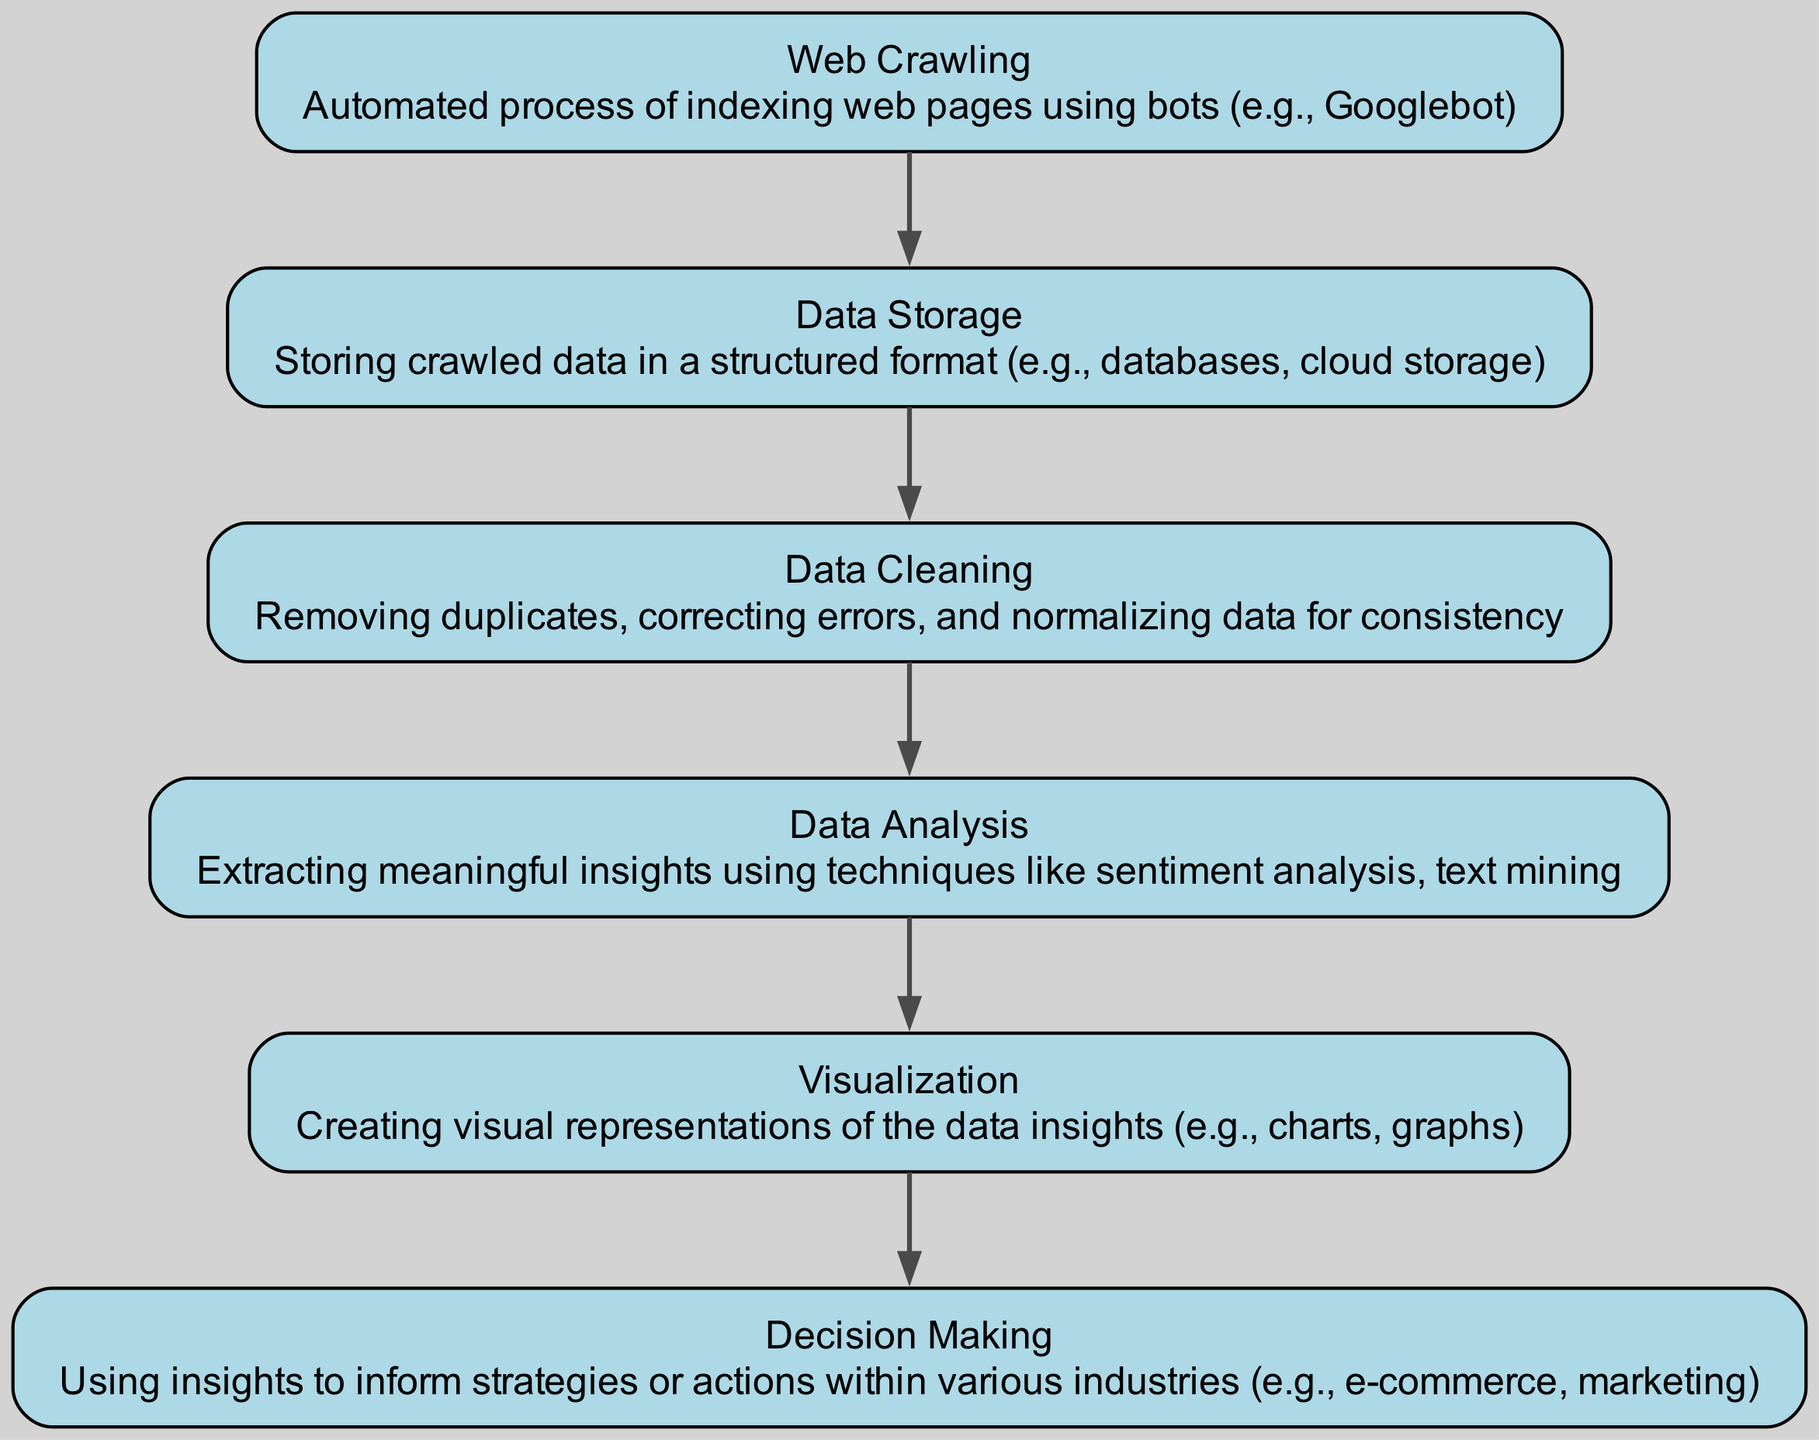What is the first step in the diagram? The first step, as indicated by the top node in the flow chart, is "Web Crawling," which represents the automated process of indexing web pages using bots.
Answer: Web Crawling How many nodes are present in the diagram? The diagram contains a total of six nodes, each representing different steps in the data extraction process from crawled sites.
Answer: Six Which step follows Data Storage? The step that follows Data Storage in the flow chart is "Data Cleaning," indicating that after storing the crawled data, it must be cleaned before further analysis.
Answer: Data Cleaning What type of analysis is performed in the Data Analysis step? The Data Analysis step involves extracting meaningful insights using techniques such as sentiment analysis and text mining, which are critical for understanding the data.
Answer: Sentiment analysis, text mining What is the relationship between Visualization and Decision Making? Visualization is connected to Decision Making in the flow chart, indicating that insights created through visualization are used to inform strategies or actions within various industries.
Answer: Insights inform strategies 